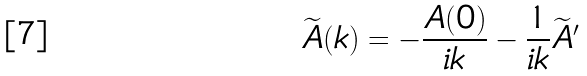Convert formula to latex. <formula><loc_0><loc_0><loc_500><loc_500>\widetilde { A } ( k ) = - \frac { A ( 0 ) } { i k } - \frac { 1 } { i k } \widetilde { A } ^ { \prime }</formula> 